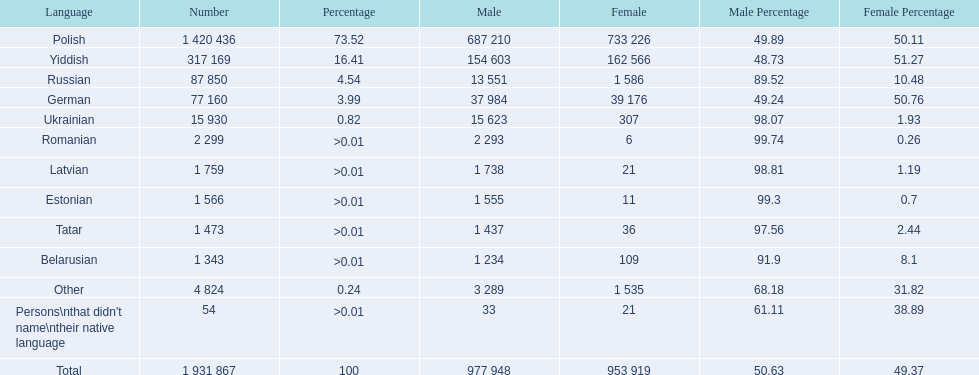What are all of the languages Polish, Yiddish, Russian, German, Ukrainian, Romanian, Latvian, Estonian, Tatar, Belarusian, Other, Persons\nthat didn't name\ntheir native language. What was the percentage of each? 73.52, 16.41, 4.54, 3.99, 0.82, >0.01, >0.01, >0.01, >0.01, >0.01, 0.24, >0.01. Which languages had a >0.01	 percentage? Romanian, Latvian, Estonian, Tatar, Belarusian. And of those, which is listed first? Romanian. 